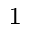<formula> <loc_0><loc_0><loc_500><loc_500>^ { 1 }</formula> 